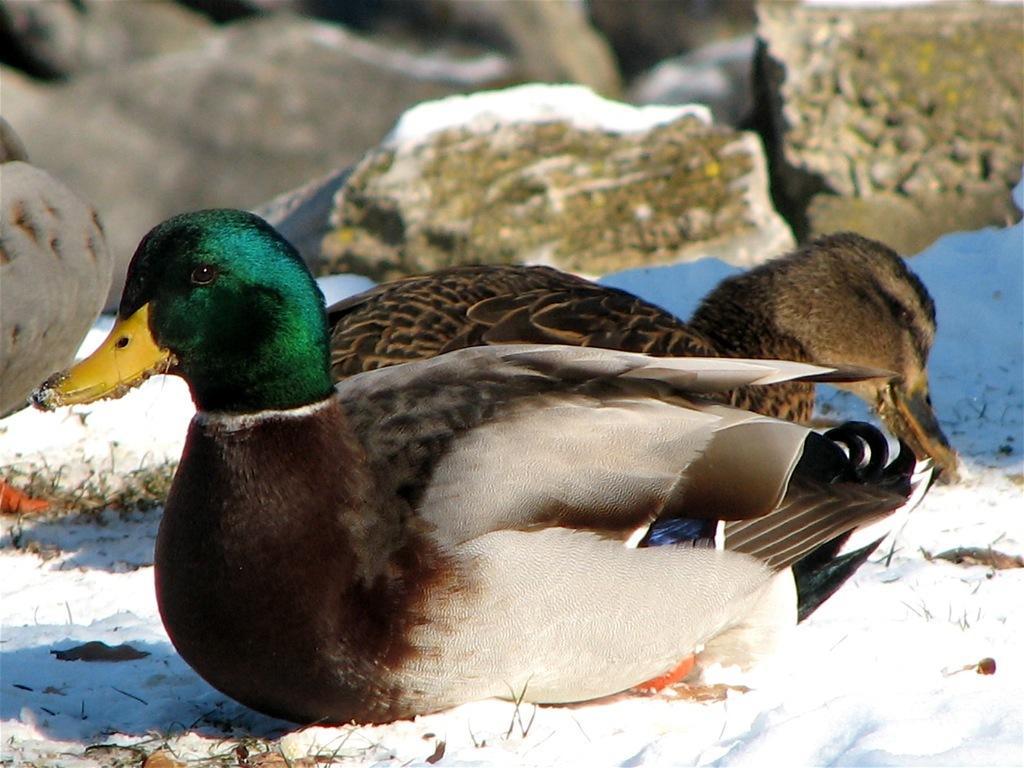Could you give a brief overview of what you see in this image? In this picture we can see birds and in the background we can see snow and some stones. 